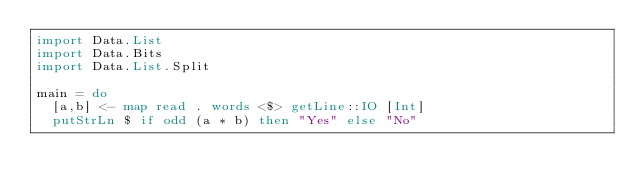<code> <loc_0><loc_0><loc_500><loc_500><_Haskell_>import Data.List
import Data.Bits
import Data.List.Split

main = do
  [a,b] <- map read . words <$> getLine::IO [Int]
  putStrLn $ if odd (a * b) then "Yes" else "No"</code> 